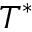<formula> <loc_0><loc_0><loc_500><loc_500>T ^ { * }</formula> 